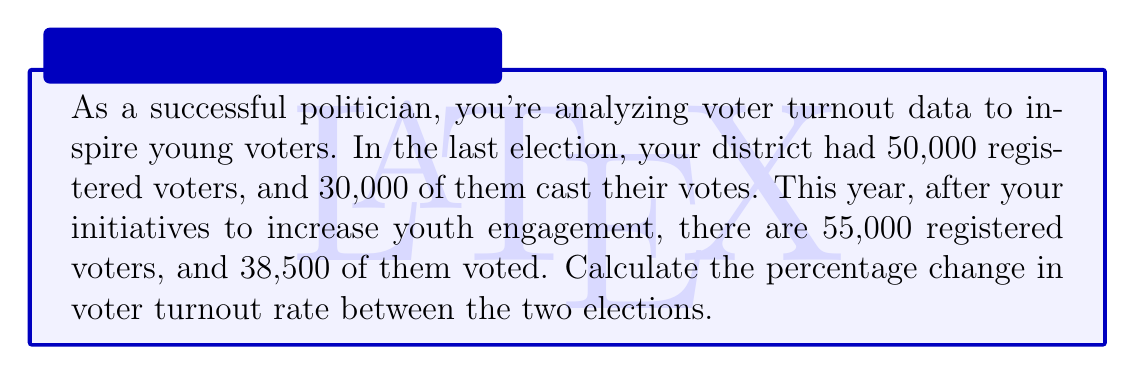Can you solve this math problem? To solve this problem, we need to follow these steps:

1. Calculate the voter turnout rate for each election:
   
   Last election turnout rate = $\frac{\text{Voters who cast votes}}{\text{Registered voters}} \times 100\%$
   
   $\text{Last election turnout rate} = \frac{30,000}{50,000} \times 100\% = 60\%$

   This year's turnout rate = $\frac{38,500}{55,000} \times 100\% = 70\%$

2. Calculate the percentage change using the formula:

   $\text{Percentage change} = \frac{\text{New value} - \text{Original value}}{\text{Original value}} \times 100\%$

   $\text{Percentage change} = \frac{70\% - 60\%}{60\%} \times 100\%$

   $= \frac{10\%}{60\%} \times 100\%$
   
   $= 0.1667 \times 100\%$
   
   $= 16.67\%$

Therefore, the percentage change in voter turnout rate between the two elections is an increase of 16.67%.
Answer: The percentage change in voter turnout rate is an increase of 16.67%. 